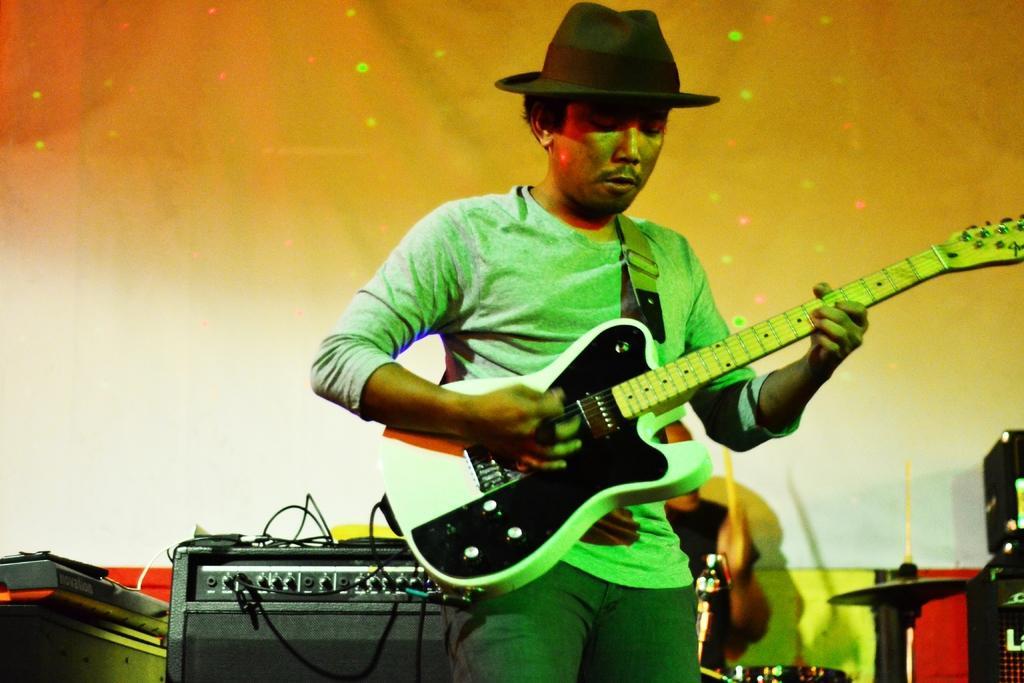Please provide a concise description of this image. This is the picture of a man playing a guitar and wearing a hat. Behind the man there are some music systems and a man in black t shirt was sitting and playing some music items. Background of these people is a screen. 